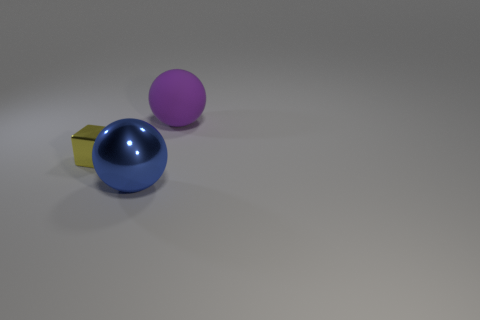Add 2 blue balls. How many objects exist? 5 Subtract 1 yellow cubes. How many objects are left? 2 Subtract all spheres. How many objects are left? 1 Subtract all spheres. Subtract all yellow metal blocks. How many objects are left? 0 Add 1 cubes. How many cubes are left? 2 Add 2 small green metallic spheres. How many small green metallic spheres exist? 2 